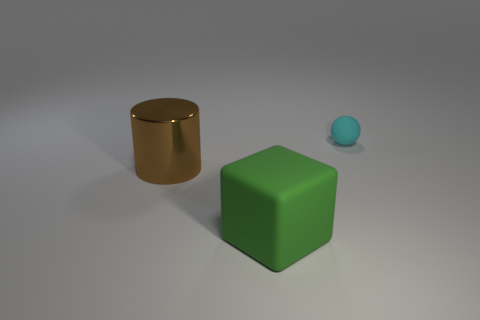Is the large brown cylinder made of the same material as the small object?
Give a very brief answer. No. What is the shape of the large object behind the matte object in front of the matte thing that is behind the big green rubber block?
Make the answer very short. Cylinder. There is a object that is both behind the green rubber thing and to the right of the big brown metal cylinder; what is its material?
Make the answer very short. Rubber. The rubber object behind the matte thing to the left of the thing that is behind the large metal thing is what color?
Your answer should be compact. Cyan. How many green objects are small rubber objects or large cylinders?
Offer a very short reply. 0. How many other objects are there of the same size as the brown metal cylinder?
Ensure brevity in your answer.  1. How many small spheres are there?
Ensure brevity in your answer.  1. Is there anything else that is the same shape as the big rubber thing?
Provide a succinct answer. No. Is the material of the object that is left of the green block the same as the thing that is in front of the brown thing?
Make the answer very short. No. What material is the tiny cyan sphere?
Ensure brevity in your answer.  Rubber. 